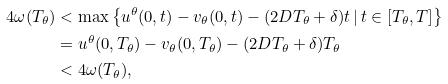<formula> <loc_0><loc_0><loc_500><loc_500>4 \omega ( T _ { \theta } ) & < \max \left \{ u ^ { \theta } ( 0 , t ) - v _ { \theta } ( 0 , t ) - ( 2 D T _ { \theta } + \delta ) t \, | \, t \in [ T _ { \theta } , T ] \right \} \\ & = u ^ { \theta } ( 0 , T _ { \theta } ) - v _ { \theta } ( 0 , T _ { \theta } ) - ( 2 D T _ { \theta } + \delta ) T _ { \theta } \\ & < 4 \omega ( T _ { \theta } ) ,</formula> 